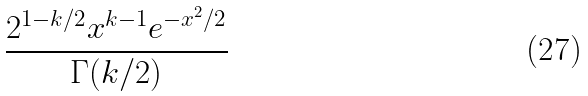<formula> <loc_0><loc_0><loc_500><loc_500>\frac { 2 ^ { 1 - k / 2 } x ^ { k - 1 } e ^ { - x ^ { 2 } / 2 } } { \Gamma ( k / 2 ) }</formula> 